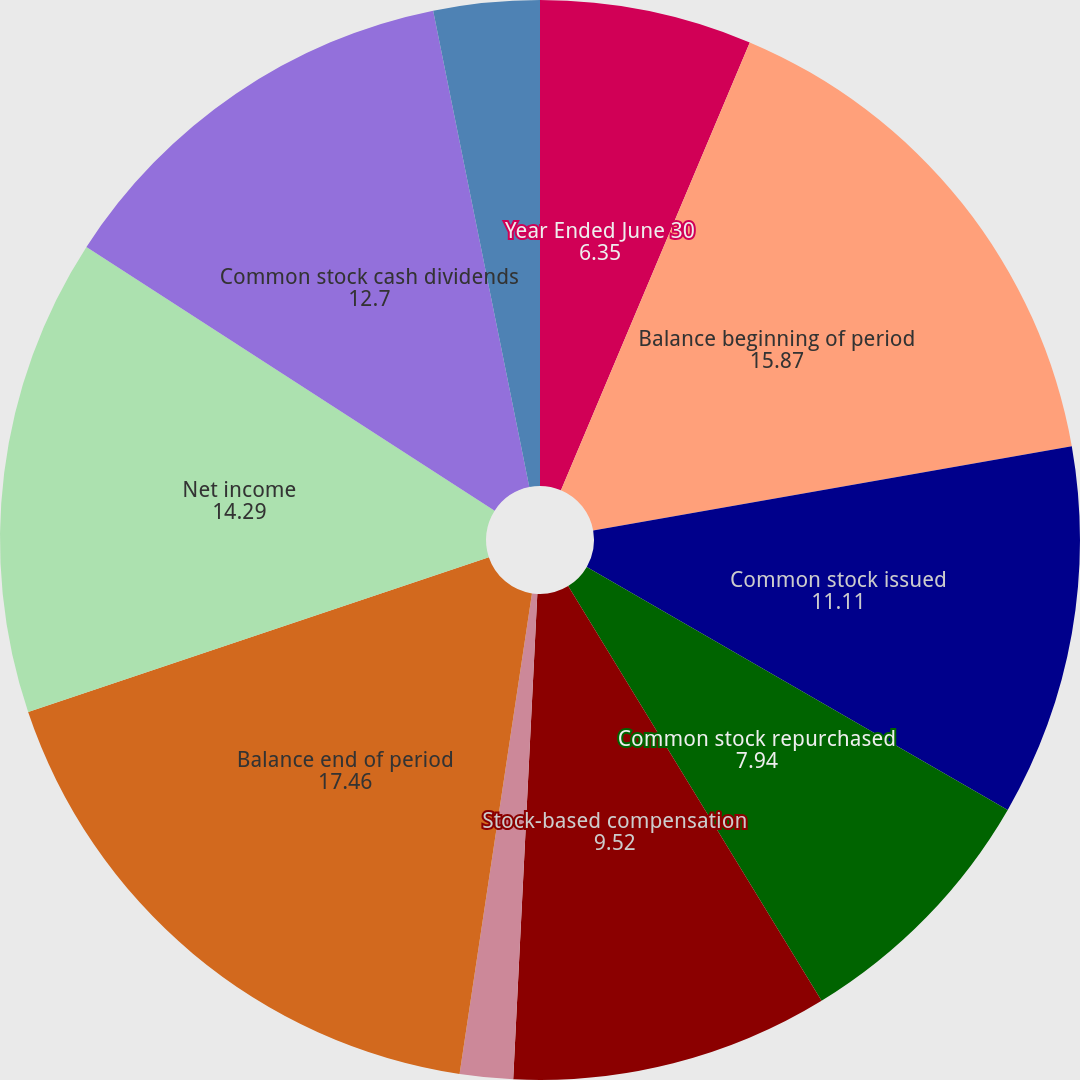<chart> <loc_0><loc_0><loc_500><loc_500><pie_chart><fcel>Year Ended June 30<fcel>Balance beginning of period<fcel>Common stock issued<fcel>Common stock repurchased<fcel>Stock-based compensation<fcel>Other net<fcel>Balance end of period<fcel>Net income<fcel>Common stock cash dividends<fcel>Cumulative effect of<nl><fcel>6.35%<fcel>15.87%<fcel>11.11%<fcel>7.94%<fcel>9.52%<fcel>1.59%<fcel>17.46%<fcel>14.29%<fcel>12.7%<fcel>3.17%<nl></chart> 